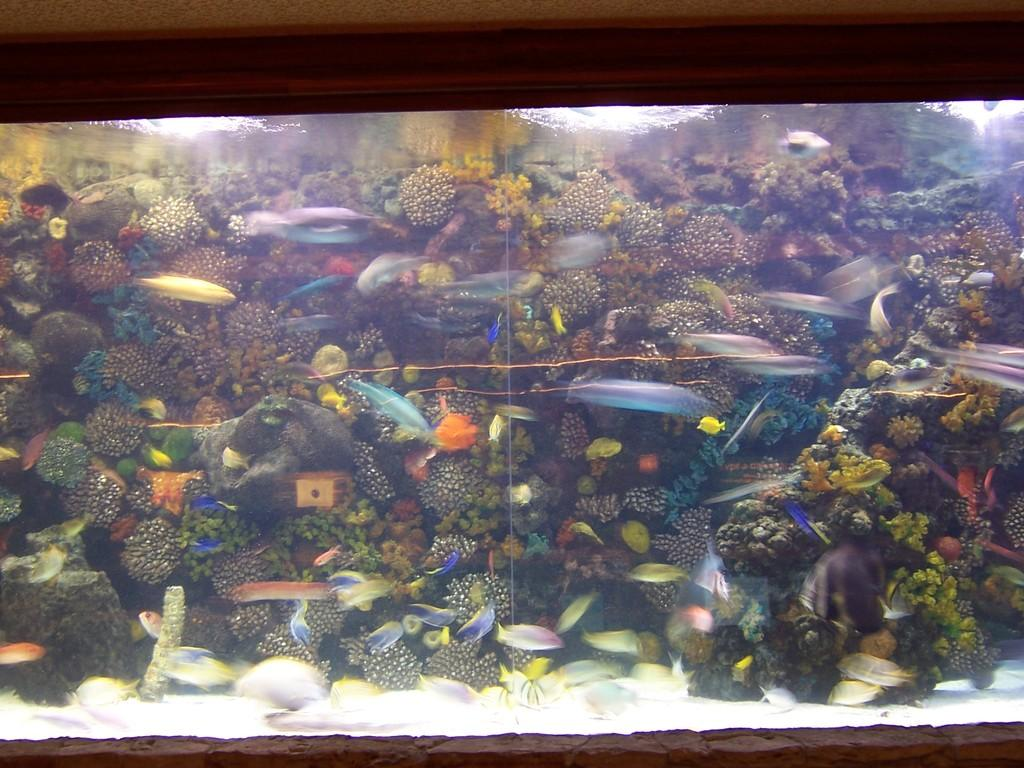What is the main object in the image? There is an aquarium in the image. What can be found inside the aquarium? The aquarium contains fishes and plants. What is the medium in which the fishes and plants are situated? There is water in the aquarium. How would you describe the overall color scheme of the image? The background of the image is dark in color. Can you see a frog looking out of the aquarium in the image? There is no frog visible in the image; the aquarium contains fishes and plants. 